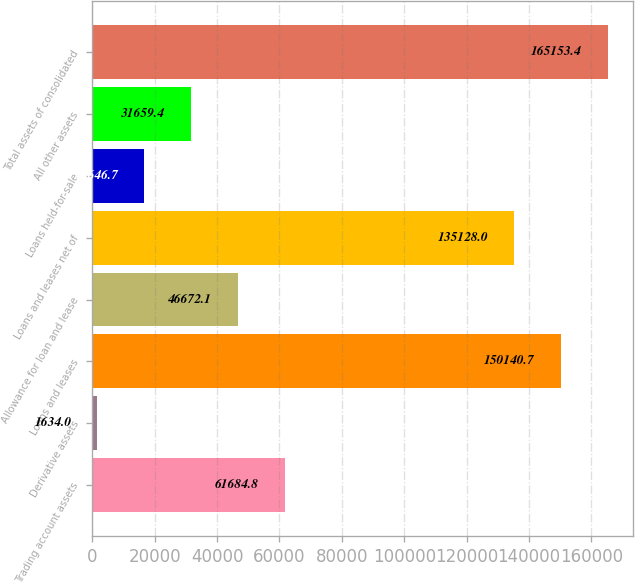Convert chart. <chart><loc_0><loc_0><loc_500><loc_500><bar_chart><fcel>Trading account assets<fcel>Derivative assets<fcel>Loans and leases<fcel>Allowance for loan and lease<fcel>Loans and leases net of<fcel>Loans held-for-sale<fcel>All other assets<fcel>Total assets of consolidated<nl><fcel>61684.8<fcel>1634<fcel>150141<fcel>46672.1<fcel>135128<fcel>16646.7<fcel>31659.4<fcel>165153<nl></chart> 